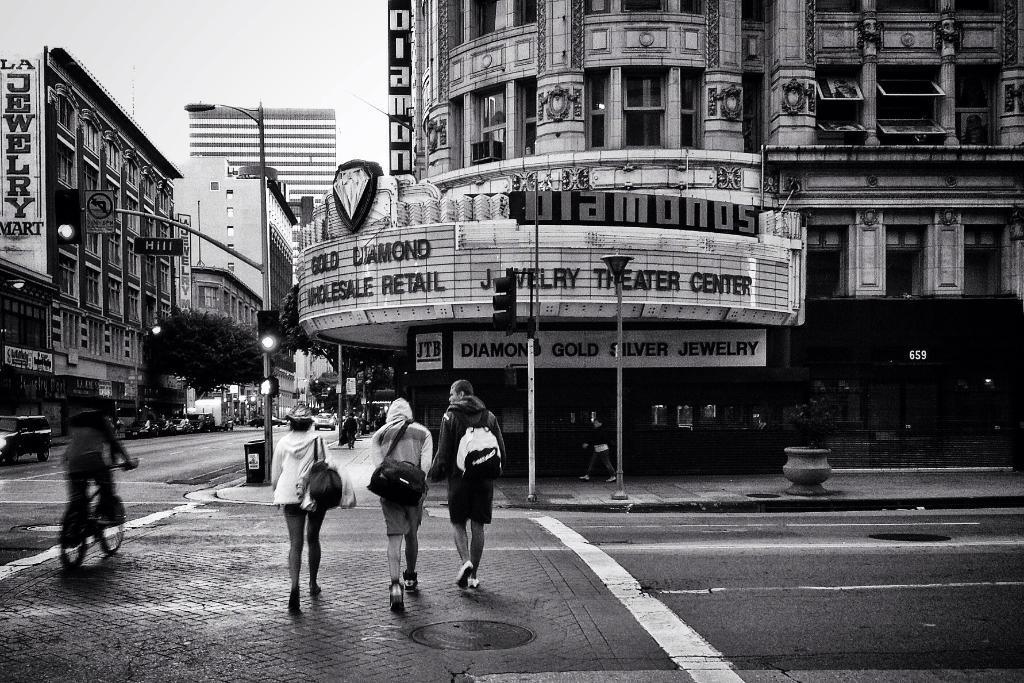Can you describe this image briefly? This is a black and white image. In this image there are roads. Three persons wearing bags and walking. Another person is riding a cycle. There are light poles and sign boards. Also there are buildings with name boards. In the background there are trees and sky. 